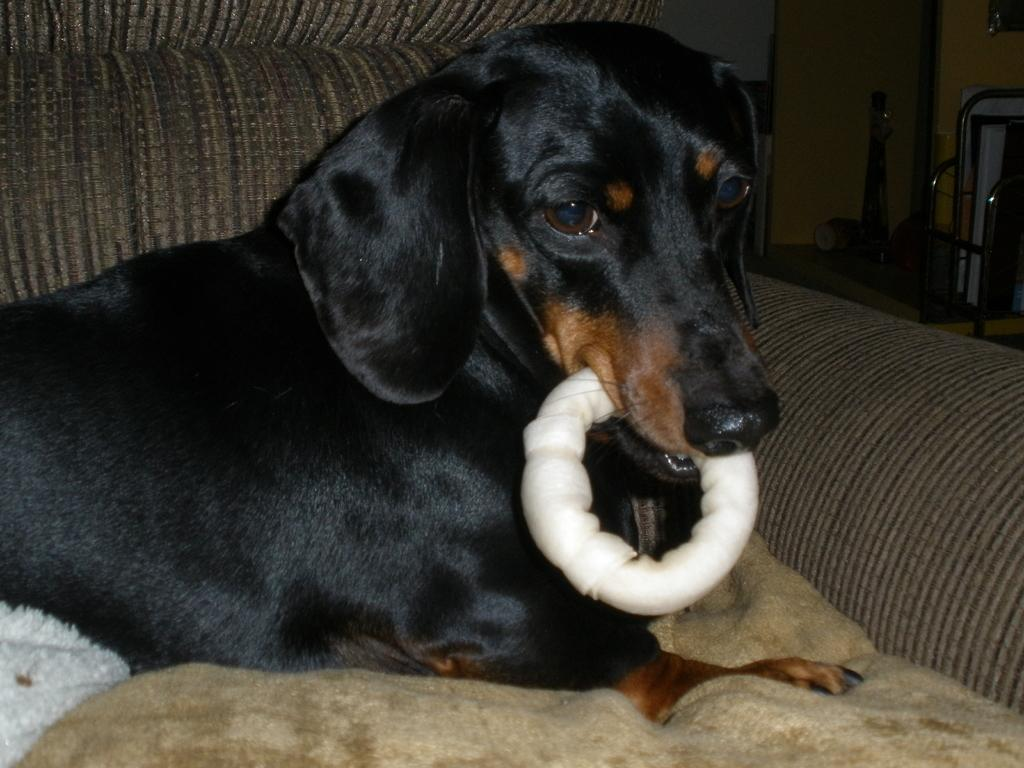What type of animal is in the image? There is a dog in the image. What color is the dog? The dog is black in color. Where is the dog located in the image? The dog is on a sofa. What can be seen at the bottom of the image? There is a brown blanket at the bottom of the image. What is on the right side of the image? There is a wall and a metal stand on the right side of the image. What type of design is featured on the wall in the image? There is no specific design mentioned in the facts, so we cannot determine the design on the wall. Is there any evidence of a crime in the image? There is no mention of a crime or any related elements in the image. 